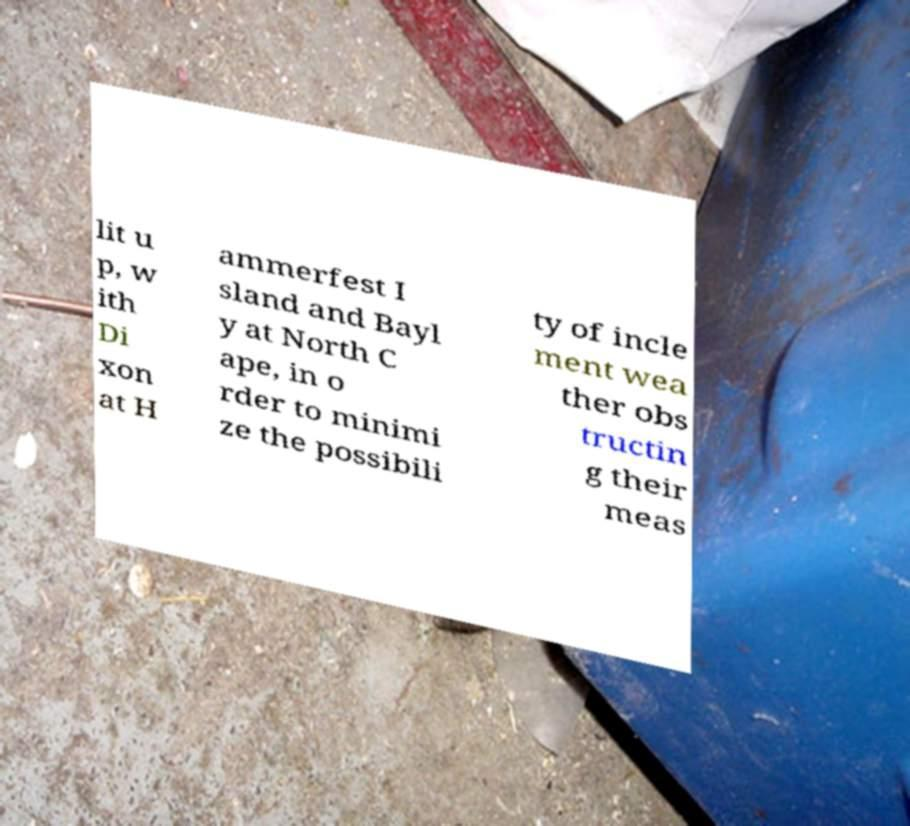Please identify and transcribe the text found in this image. lit u p, w ith Di xon at H ammerfest I sland and Bayl y at North C ape, in o rder to minimi ze the possibili ty of incle ment wea ther obs tructin g their meas 